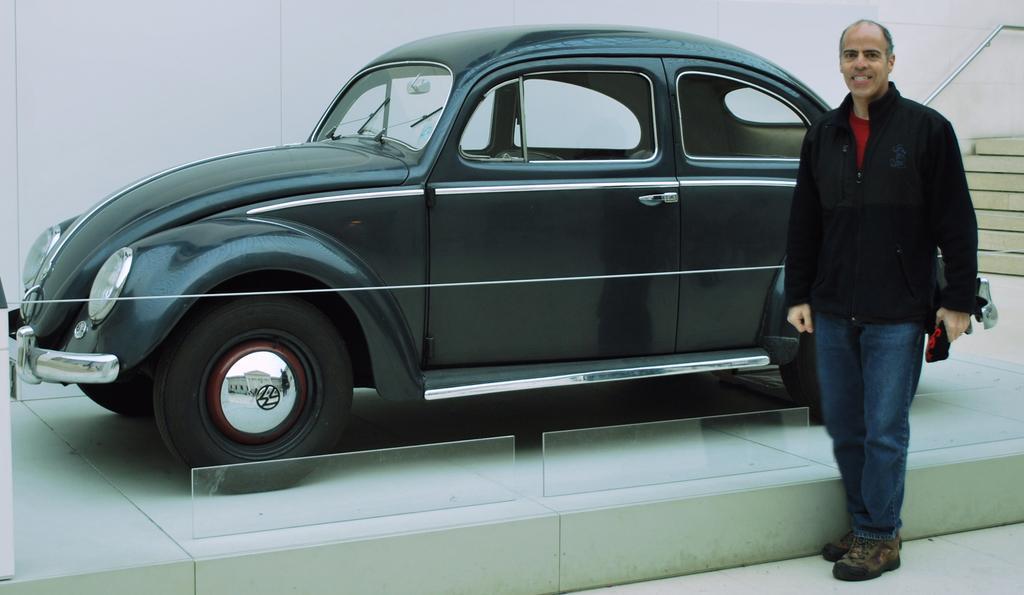Describe this image in one or two sentences. On the right there is a person standing wearing a black jacket. In the center of the picture there is a car. In the background towards right there is staircase. In the background it is wall painted white. On the left there is an object. 